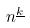Convert formula to latex. <formula><loc_0><loc_0><loc_500><loc_500>n ^ { \underline { k } }</formula> 